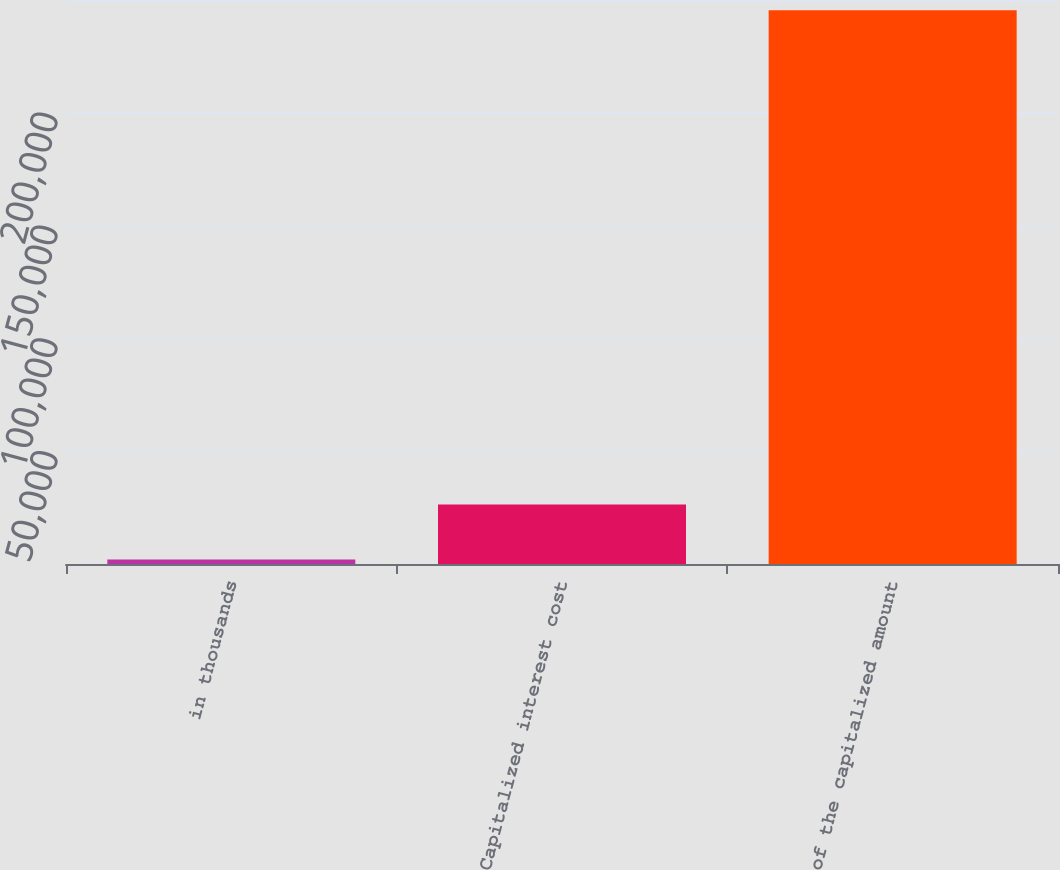Convert chart. <chart><loc_0><loc_0><loc_500><loc_500><bar_chart><fcel>in thousands<fcel>Capitalized interest cost<fcel>of the capitalized amount<nl><fcel>2014<fcel>26358.5<fcel>245459<nl></chart> 